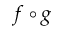Convert formula to latex. <formula><loc_0><loc_0><loc_500><loc_500>f \circ g</formula> 